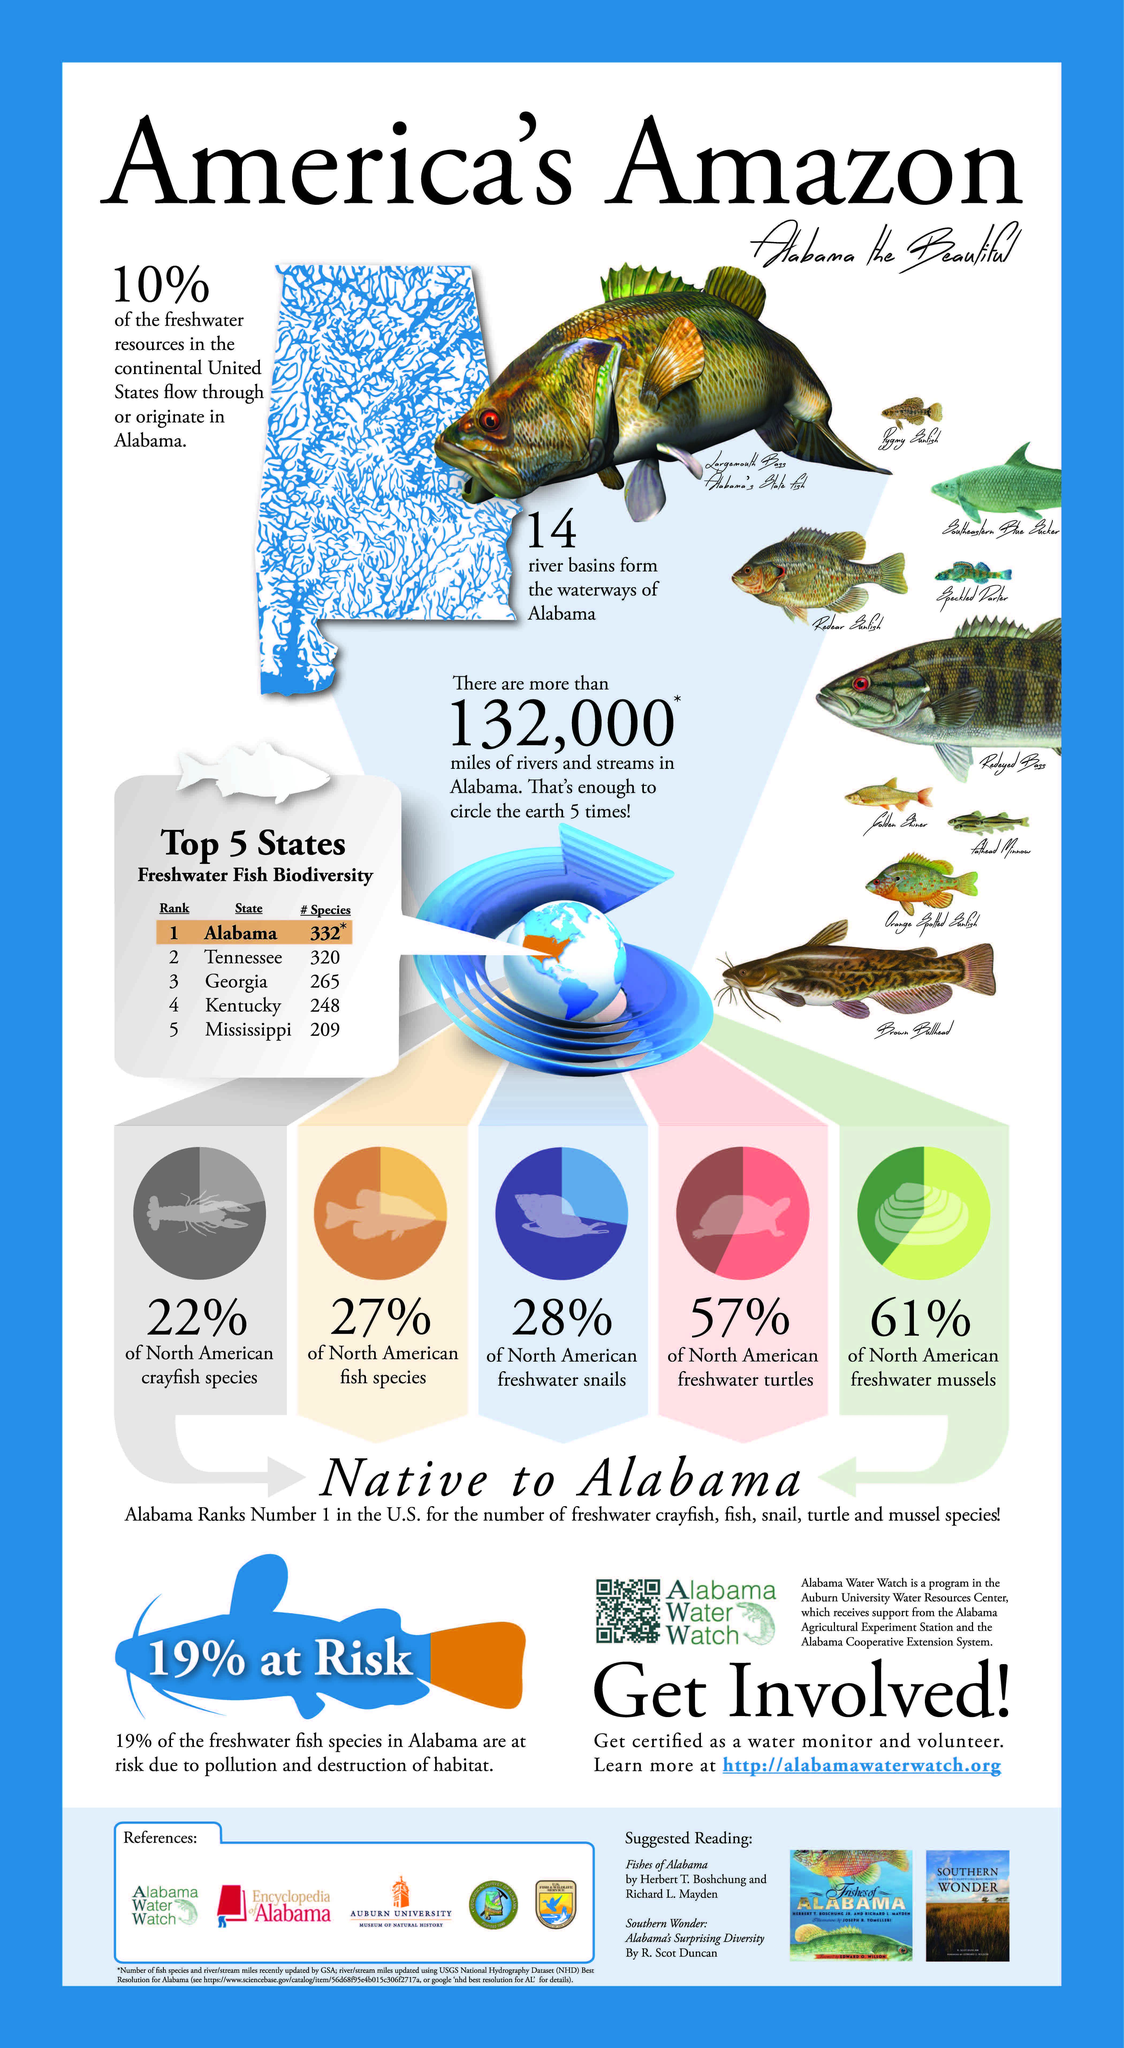Point out several critical features in this image. Alabama is the state in America that boasts the greatest diversity of freshwater fish. There are 209 species of freshwater fish found in the state of Mississippi in America. There are 320 species of freshwater fish found in the state of Tennessee. Kentucky is ranked as the fourth most diverse state in America in terms of freshwater fish. According to recent studies, a significant proportion of North American freshwater turtles can be found in the state of Alabama. Specifically, approximately 57% of these turtles are found in Alabama. 